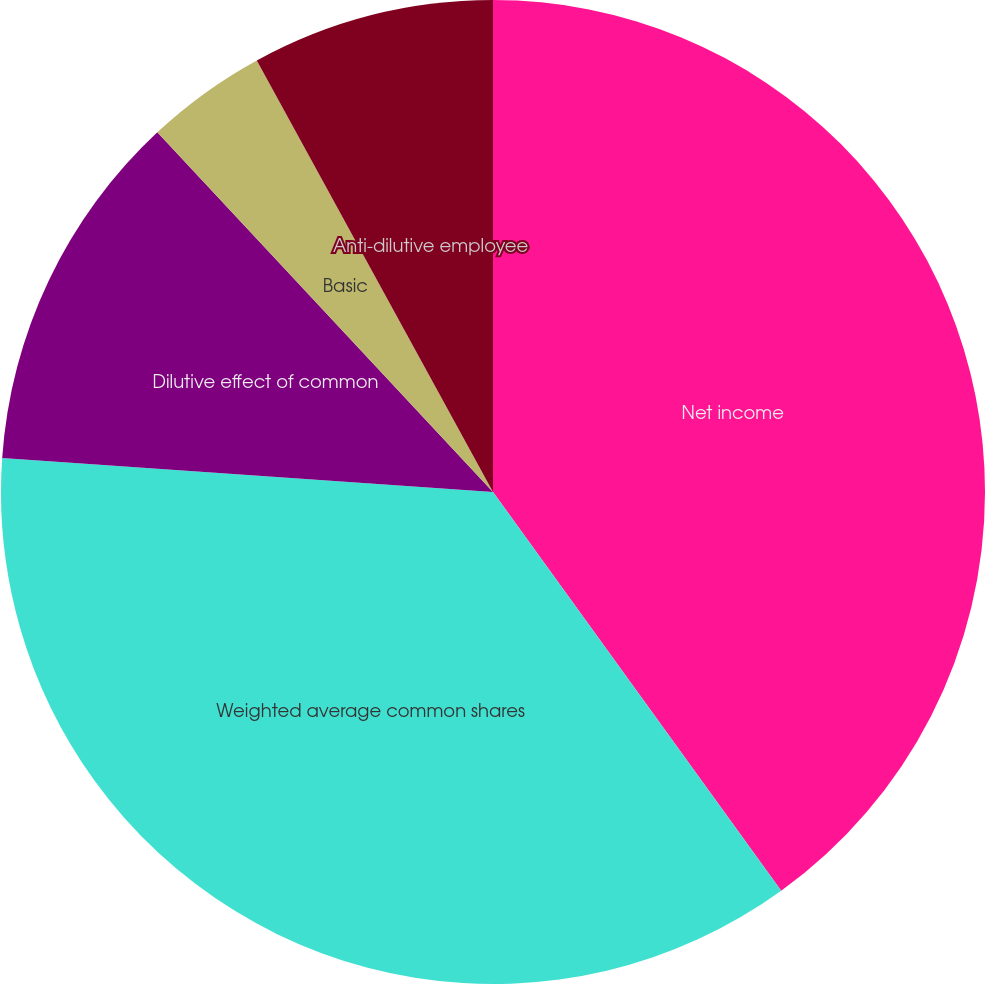<chart> <loc_0><loc_0><loc_500><loc_500><pie_chart><fcel>Net income<fcel>Weighted average common shares<fcel>Dilutive effect of common<fcel>Basic<fcel>Diluted<fcel>Anti-dilutive employee<nl><fcel>40.04%<fcel>36.06%<fcel>11.95%<fcel>3.98%<fcel>0.0%<fcel>7.97%<nl></chart> 